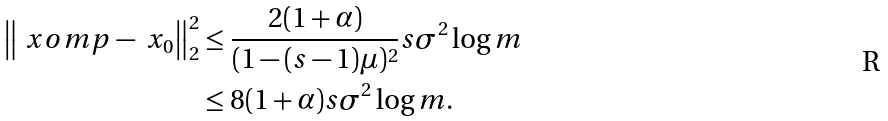<formula> <loc_0><loc_0><loc_500><loc_500>\left \| \ x o m p - \ x _ { 0 } \right \| _ { 2 } ^ { 2 } & \leq \frac { 2 ( 1 + \alpha ) } { ( 1 - ( s - 1 ) \mu ) ^ { 2 } } s \sigma ^ { 2 } \log m \\ & \leq 8 ( 1 + \alpha ) s \sigma ^ { 2 } \log m .</formula> 